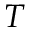<formula> <loc_0><loc_0><loc_500><loc_500>T</formula> 